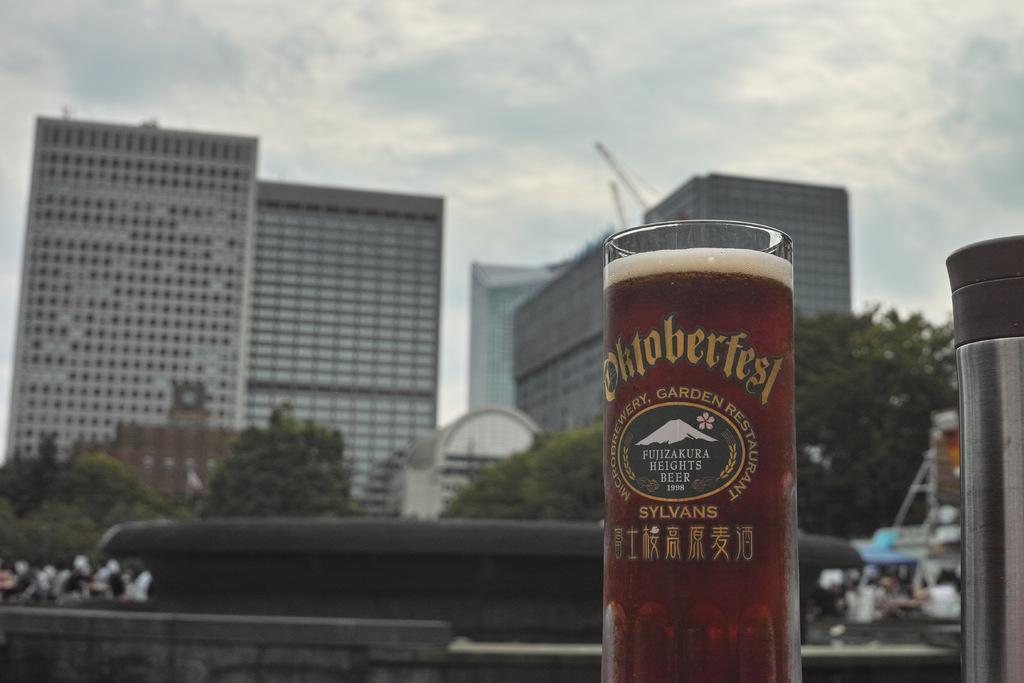What festival is the glass from?
Provide a succinct answer. Oktoberfest. The oktoberfest festival?
Ensure brevity in your answer.  Yes. 